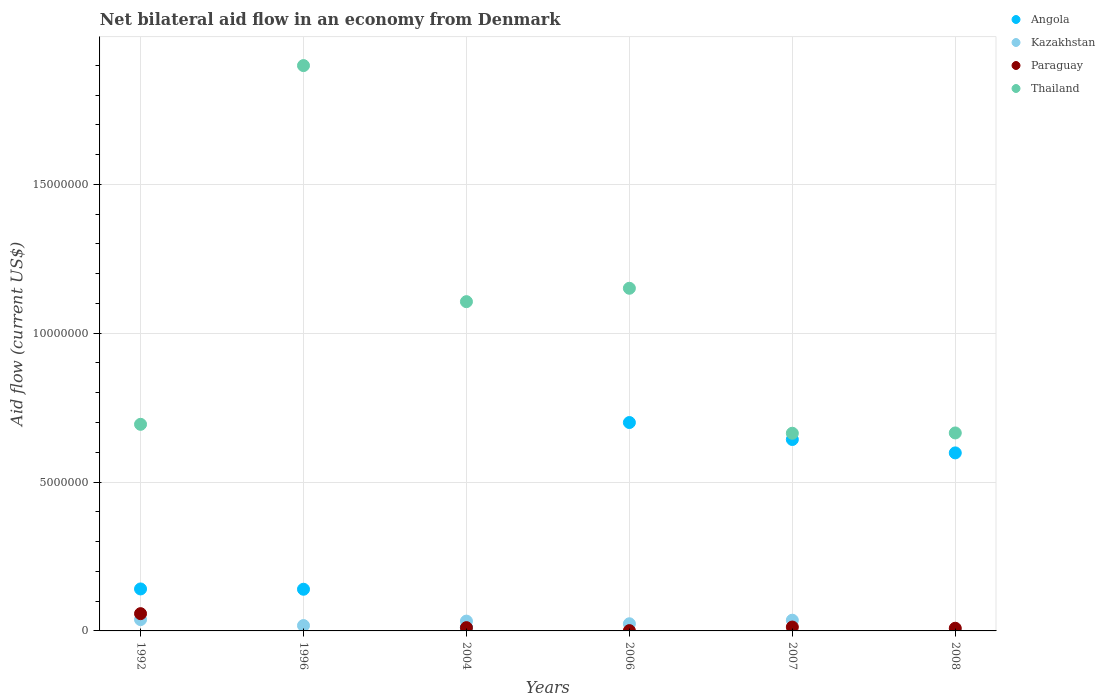In which year was the net bilateral aid flow in Kazakhstan maximum?
Your response must be concise. 1992. What is the total net bilateral aid flow in Angola in the graph?
Offer a very short reply. 2.23e+07. What is the difference between the net bilateral aid flow in Paraguay in 1996 and the net bilateral aid flow in Thailand in 2007?
Offer a terse response. -6.64e+06. What is the average net bilateral aid flow in Kazakhstan per year?
Give a very brief answer. 2.50e+05. In the year 1992, what is the difference between the net bilateral aid flow in Kazakhstan and net bilateral aid flow in Paraguay?
Ensure brevity in your answer.  -2.00e+05. In how many years, is the net bilateral aid flow in Thailand greater than 6000000 US$?
Offer a terse response. 6. What is the ratio of the net bilateral aid flow in Thailand in 2004 to that in 2008?
Your answer should be very brief. 1.66. Is the net bilateral aid flow in Angola in 1992 less than that in 2004?
Make the answer very short. No. What is the difference between the highest and the second highest net bilateral aid flow in Kazakhstan?
Keep it short and to the point. 2.00e+04. What is the difference between the highest and the lowest net bilateral aid flow in Paraguay?
Keep it short and to the point. 5.80e+05. Is the sum of the net bilateral aid flow in Kazakhstan in 1992 and 2007 greater than the maximum net bilateral aid flow in Angola across all years?
Ensure brevity in your answer.  No. Is it the case that in every year, the sum of the net bilateral aid flow in Paraguay and net bilateral aid flow in Angola  is greater than the sum of net bilateral aid flow in Thailand and net bilateral aid flow in Kazakhstan?
Your answer should be compact. Yes. Does the net bilateral aid flow in Thailand monotonically increase over the years?
Keep it short and to the point. No. Is the net bilateral aid flow in Kazakhstan strictly greater than the net bilateral aid flow in Angola over the years?
Keep it short and to the point. No. How many dotlines are there?
Ensure brevity in your answer.  4. How many years are there in the graph?
Offer a terse response. 6. Does the graph contain any zero values?
Ensure brevity in your answer.  Yes. Does the graph contain grids?
Offer a terse response. Yes. Where does the legend appear in the graph?
Offer a very short reply. Top right. How many legend labels are there?
Keep it short and to the point. 4. How are the legend labels stacked?
Ensure brevity in your answer.  Vertical. What is the title of the graph?
Keep it short and to the point. Net bilateral aid flow in an economy from Denmark. Does "Faeroe Islands" appear as one of the legend labels in the graph?
Your response must be concise. No. What is the label or title of the Y-axis?
Provide a succinct answer. Aid flow (current US$). What is the Aid flow (current US$) in Angola in 1992?
Your answer should be compact. 1.41e+06. What is the Aid flow (current US$) in Kazakhstan in 1992?
Keep it short and to the point. 3.80e+05. What is the Aid flow (current US$) of Paraguay in 1992?
Make the answer very short. 5.80e+05. What is the Aid flow (current US$) of Thailand in 1992?
Give a very brief answer. 6.94e+06. What is the Aid flow (current US$) in Angola in 1996?
Keep it short and to the point. 1.40e+06. What is the Aid flow (current US$) in Kazakhstan in 1996?
Your response must be concise. 1.80e+05. What is the Aid flow (current US$) of Thailand in 1996?
Provide a succinct answer. 1.90e+07. What is the Aid flow (current US$) of Thailand in 2004?
Provide a short and direct response. 1.11e+07. What is the Aid flow (current US$) in Angola in 2006?
Give a very brief answer. 7.00e+06. What is the Aid flow (current US$) in Kazakhstan in 2006?
Provide a short and direct response. 2.40e+05. What is the Aid flow (current US$) in Paraguay in 2006?
Ensure brevity in your answer.  10000. What is the Aid flow (current US$) in Thailand in 2006?
Keep it short and to the point. 1.15e+07. What is the Aid flow (current US$) in Angola in 2007?
Provide a short and direct response. 6.43e+06. What is the Aid flow (current US$) in Kazakhstan in 2007?
Your answer should be very brief. 3.60e+05. What is the Aid flow (current US$) in Thailand in 2007?
Your answer should be compact. 6.64e+06. What is the Aid flow (current US$) of Angola in 2008?
Ensure brevity in your answer.  5.98e+06. What is the Aid flow (current US$) in Kazakhstan in 2008?
Make the answer very short. 10000. What is the Aid flow (current US$) in Thailand in 2008?
Offer a very short reply. 6.65e+06. Across all years, what is the maximum Aid flow (current US$) of Angola?
Your answer should be compact. 7.00e+06. Across all years, what is the maximum Aid flow (current US$) in Paraguay?
Your response must be concise. 5.80e+05. Across all years, what is the maximum Aid flow (current US$) in Thailand?
Offer a terse response. 1.90e+07. Across all years, what is the minimum Aid flow (current US$) in Kazakhstan?
Provide a short and direct response. 10000. Across all years, what is the minimum Aid flow (current US$) of Paraguay?
Provide a succinct answer. 0. Across all years, what is the minimum Aid flow (current US$) in Thailand?
Provide a short and direct response. 6.64e+06. What is the total Aid flow (current US$) in Angola in the graph?
Give a very brief answer. 2.23e+07. What is the total Aid flow (current US$) in Kazakhstan in the graph?
Make the answer very short. 1.50e+06. What is the total Aid flow (current US$) of Paraguay in the graph?
Provide a short and direct response. 9.20e+05. What is the total Aid flow (current US$) in Thailand in the graph?
Your answer should be very brief. 6.18e+07. What is the difference between the Aid flow (current US$) of Thailand in 1992 and that in 1996?
Your answer should be very brief. -1.20e+07. What is the difference between the Aid flow (current US$) in Angola in 1992 and that in 2004?
Your answer should be compact. 1.29e+06. What is the difference between the Aid flow (current US$) in Kazakhstan in 1992 and that in 2004?
Your response must be concise. 5.00e+04. What is the difference between the Aid flow (current US$) in Paraguay in 1992 and that in 2004?
Your answer should be compact. 4.70e+05. What is the difference between the Aid flow (current US$) of Thailand in 1992 and that in 2004?
Offer a terse response. -4.12e+06. What is the difference between the Aid flow (current US$) in Angola in 1992 and that in 2006?
Your response must be concise. -5.59e+06. What is the difference between the Aid flow (current US$) in Kazakhstan in 1992 and that in 2006?
Keep it short and to the point. 1.40e+05. What is the difference between the Aid flow (current US$) of Paraguay in 1992 and that in 2006?
Make the answer very short. 5.70e+05. What is the difference between the Aid flow (current US$) of Thailand in 1992 and that in 2006?
Provide a short and direct response. -4.57e+06. What is the difference between the Aid flow (current US$) in Angola in 1992 and that in 2007?
Provide a succinct answer. -5.02e+06. What is the difference between the Aid flow (current US$) in Kazakhstan in 1992 and that in 2007?
Provide a succinct answer. 2.00e+04. What is the difference between the Aid flow (current US$) in Thailand in 1992 and that in 2007?
Offer a terse response. 3.00e+05. What is the difference between the Aid flow (current US$) of Angola in 1992 and that in 2008?
Keep it short and to the point. -4.57e+06. What is the difference between the Aid flow (current US$) of Thailand in 1992 and that in 2008?
Offer a very short reply. 2.90e+05. What is the difference between the Aid flow (current US$) in Angola in 1996 and that in 2004?
Give a very brief answer. 1.28e+06. What is the difference between the Aid flow (current US$) of Thailand in 1996 and that in 2004?
Provide a short and direct response. 7.93e+06. What is the difference between the Aid flow (current US$) of Angola in 1996 and that in 2006?
Give a very brief answer. -5.60e+06. What is the difference between the Aid flow (current US$) of Thailand in 1996 and that in 2006?
Your answer should be compact. 7.48e+06. What is the difference between the Aid flow (current US$) of Angola in 1996 and that in 2007?
Your response must be concise. -5.03e+06. What is the difference between the Aid flow (current US$) in Thailand in 1996 and that in 2007?
Your answer should be compact. 1.24e+07. What is the difference between the Aid flow (current US$) in Angola in 1996 and that in 2008?
Keep it short and to the point. -4.58e+06. What is the difference between the Aid flow (current US$) in Thailand in 1996 and that in 2008?
Offer a terse response. 1.23e+07. What is the difference between the Aid flow (current US$) in Angola in 2004 and that in 2006?
Keep it short and to the point. -6.88e+06. What is the difference between the Aid flow (current US$) in Kazakhstan in 2004 and that in 2006?
Provide a short and direct response. 9.00e+04. What is the difference between the Aid flow (current US$) in Thailand in 2004 and that in 2006?
Give a very brief answer. -4.50e+05. What is the difference between the Aid flow (current US$) of Angola in 2004 and that in 2007?
Ensure brevity in your answer.  -6.31e+06. What is the difference between the Aid flow (current US$) in Paraguay in 2004 and that in 2007?
Your answer should be very brief. -2.00e+04. What is the difference between the Aid flow (current US$) of Thailand in 2004 and that in 2007?
Your answer should be compact. 4.42e+06. What is the difference between the Aid flow (current US$) in Angola in 2004 and that in 2008?
Provide a short and direct response. -5.86e+06. What is the difference between the Aid flow (current US$) of Paraguay in 2004 and that in 2008?
Offer a terse response. 2.00e+04. What is the difference between the Aid flow (current US$) of Thailand in 2004 and that in 2008?
Keep it short and to the point. 4.41e+06. What is the difference between the Aid flow (current US$) of Angola in 2006 and that in 2007?
Make the answer very short. 5.70e+05. What is the difference between the Aid flow (current US$) of Kazakhstan in 2006 and that in 2007?
Provide a short and direct response. -1.20e+05. What is the difference between the Aid flow (current US$) in Paraguay in 2006 and that in 2007?
Offer a very short reply. -1.20e+05. What is the difference between the Aid flow (current US$) in Thailand in 2006 and that in 2007?
Offer a very short reply. 4.87e+06. What is the difference between the Aid flow (current US$) in Angola in 2006 and that in 2008?
Your response must be concise. 1.02e+06. What is the difference between the Aid flow (current US$) in Paraguay in 2006 and that in 2008?
Your response must be concise. -8.00e+04. What is the difference between the Aid flow (current US$) of Thailand in 2006 and that in 2008?
Provide a short and direct response. 4.86e+06. What is the difference between the Aid flow (current US$) in Angola in 2007 and that in 2008?
Provide a short and direct response. 4.50e+05. What is the difference between the Aid flow (current US$) of Thailand in 2007 and that in 2008?
Your answer should be compact. -10000. What is the difference between the Aid flow (current US$) of Angola in 1992 and the Aid flow (current US$) of Kazakhstan in 1996?
Provide a succinct answer. 1.23e+06. What is the difference between the Aid flow (current US$) in Angola in 1992 and the Aid flow (current US$) in Thailand in 1996?
Your response must be concise. -1.76e+07. What is the difference between the Aid flow (current US$) in Kazakhstan in 1992 and the Aid flow (current US$) in Thailand in 1996?
Offer a very short reply. -1.86e+07. What is the difference between the Aid flow (current US$) in Paraguay in 1992 and the Aid flow (current US$) in Thailand in 1996?
Offer a terse response. -1.84e+07. What is the difference between the Aid flow (current US$) in Angola in 1992 and the Aid flow (current US$) in Kazakhstan in 2004?
Offer a very short reply. 1.08e+06. What is the difference between the Aid flow (current US$) of Angola in 1992 and the Aid flow (current US$) of Paraguay in 2004?
Provide a short and direct response. 1.30e+06. What is the difference between the Aid flow (current US$) of Angola in 1992 and the Aid flow (current US$) of Thailand in 2004?
Ensure brevity in your answer.  -9.65e+06. What is the difference between the Aid flow (current US$) of Kazakhstan in 1992 and the Aid flow (current US$) of Thailand in 2004?
Offer a terse response. -1.07e+07. What is the difference between the Aid flow (current US$) in Paraguay in 1992 and the Aid flow (current US$) in Thailand in 2004?
Provide a short and direct response. -1.05e+07. What is the difference between the Aid flow (current US$) in Angola in 1992 and the Aid flow (current US$) in Kazakhstan in 2006?
Provide a short and direct response. 1.17e+06. What is the difference between the Aid flow (current US$) in Angola in 1992 and the Aid flow (current US$) in Paraguay in 2006?
Give a very brief answer. 1.40e+06. What is the difference between the Aid flow (current US$) of Angola in 1992 and the Aid flow (current US$) of Thailand in 2006?
Your answer should be compact. -1.01e+07. What is the difference between the Aid flow (current US$) in Kazakhstan in 1992 and the Aid flow (current US$) in Thailand in 2006?
Offer a terse response. -1.11e+07. What is the difference between the Aid flow (current US$) in Paraguay in 1992 and the Aid flow (current US$) in Thailand in 2006?
Make the answer very short. -1.09e+07. What is the difference between the Aid flow (current US$) in Angola in 1992 and the Aid flow (current US$) in Kazakhstan in 2007?
Ensure brevity in your answer.  1.05e+06. What is the difference between the Aid flow (current US$) in Angola in 1992 and the Aid flow (current US$) in Paraguay in 2007?
Offer a very short reply. 1.28e+06. What is the difference between the Aid flow (current US$) of Angola in 1992 and the Aid flow (current US$) of Thailand in 2007?
Provide a short and direct response. -5.23e+06. What is the difference between the Aid flow (current US$) in Kazakhstan in 1992 and the Aid flow (current US$) in Thailand in 2007?
Your answer should be very brief. -6.26e+06. What is the difference between the Aid flow (current US$) of Paraguay in 1992 and the Aid flow (current US$) of Thailand in 2007?
Provide a succinct answer. -6.06e+06. What is the difference between the Aid flow (current US$) of Angola in 1992 and the Aid flow (current US$) of Kazakhstan in 2008?
Your response must be concise. 1.40e+06. What is the difference between the Aid flow (current US$) in Angola in 1992 and the Aid flow (current US$) in Paraguay in 2008?
Offer a terse response. 1.32e+06. What is the difference between the Aid flow (current US$) in Angola in 1992 and the Aid flow (current US$) in Thailand in 2008?
Provide a succinct answer. -5.24e+06. What is the difference between the Aid flow (current US$) in Kazakhstan in 1992 and the Aid flow (current US$) in Thailand in 2008?
Give a very brief answer. -6.27e+06. What is the difference between the Aid flow (current US$) in Paraguay in 1992 and the Aid flow (current US$) in Thailand in 2008?
Your answer should be compact. -6.07e+06. What is the difference between the Aid flow (current US$) of Angola in 1996 and the Aid flow (current US$) of Kazakhstan in 2004?
Your answer should be compact. 1.07e+06. What is the difference between the Aid flow (current US$) of Angola in 1996 and the Aid flow (current US$) of Paraguay in 2004?
Offer a very short reply. 1.29e+06. What is the difference between the Aid flow (current US$) of Angola in 1996 and the Aid flow (current US$) of Thailand in 2004?
Keep it short and to the point. -9.66e+06. What is the difference between the Aid flow (current US$) of Kazakhstan in 1996 and the Aid flow (current US$) of Thailand in 2004?
Your answer should be very brief. -1.09e+07. What is the difference between the Aid flow (current US$) of Angola in 1996 and the Aid flow (current US$) of Kazakhstan in 2006?
Provide a succinct answer. 1.16e+06. What is the difference between the Aid flow (current US$) of Angola in 1996 and the Aid flow (current US$) of Paraguay in 2006?
Give a very brief answer. 1.39e+06. What is the difference between the Aid flow (current US$) of Angola in 1996 and the Aid flow (current US$) of Thailand in 2006?
Offer a terse response. -1.01e+07. What is the difference between the Aid flow (current US$) in Kazakhstan in 1996 and the Aid flow (current US$) in Thailand in 2006?
Provide a succinct answer. -1.13e+07. What is the difference between the Aid flow (current US$) of Angola in 1996 and the Aid flow (current US$) of Kazakhstan in 2007?
Keep it short and to the point. 1.04e+06. What is the difference between the Aid flow (current US$) of Angola in 1996 and the Aid flow (current US$) of Paraguay in 2007?
Offer a terse response. 1.27e+06. What is the difference between the Aid flow (current US$) of Angola in 1996 and the Aid flow (current US$) of Thailand in 2007?
Your answer should be very brief. -5.24e+06. What is the difference between the Aid flow (current US$) of Kazakhstan in 1996 and the Aid flow (current US$) of Paraguay in 2007?
Give a very brief answer. 5.00e+04. What is the difference between the Aid flow (current US$) in Kazakhstan in 1996 and the Aid flow (current US$) in Thailand in 2007?
Keep it short and to the point. -6.46e+06. What is the difference between the Aid flow (current US$) in Angola in 1996 and the Aid flow (current US$) in Kazakhstan in 2008?
Provide a short and direct response. 1.39e+06. What is the difference between the Aid flow (current US$) of Angola in 1996 and the Aid flow (current US$) of Paraguay in 2008?
Offer a very short reply. 1.31e+06. What is the difference between the Aid flow (current US$) in Angola in 1996 and the Aid flow (current US$) in Thailand in 2008?
Your response must be concise. -5.25e+06. What is the difference between the Aid flow (current US$) in Kazakhstan in 1996 and the Aid flow (current US$) in Paraguay in 2008?
Give a very brief answer. 9.00e+04. What is the difference between the Aid flow (current US$) in Kazakhstan in 1996 and the Aid flow (current US$) in Thailand in 2008?
Provide a short and direct response. -6.47e+06. What is the difference between the Aid flow (current US$) of Angola in 2004 and the Aid flow (current US$) of Kazakhstan in 2006?
Make the answer very short. -1.20e+05. What is the difference between the Aid flow (current US$) in Angola in 2004 and the Aid flow (current US$) in Thailand in 2006?
Offer a terse response. -1.14e+07. What is the difference between the Aid flow (current US$) in Kazakhstan in 2004 and the Aid flow (current US$) in Thailand in 2006?
Provide a succinct answer. -1.12e+07. What is the difference between the Aid flow (current US$) in Paraguay in 2004 and the Aid flow (current US$) in Thailand in 2006?
Ensure brevity in your answer.  -1.14e+07. What is the difference between the Aid flow (current US$) of Angola in 2004 and the Aid flow (current US$) of Kazakhstan in 2007?
Provide a short and direct response. -2.40e+05. What is the difference between the Aid flow (current US$) in Angola in 2004 and the Aid flow (current US$) in Thailand in 2007?
Ensure brevity in your answer.  -6.52e+06. What is the difference between the Aid flow (current US$) in Kazakhstan in 2004 and the Aid flow (current US$) in Paraguay in 2007?
Offer a terse response. 2.00e+05. What is the difference between the Aid flow (current US$) of Kazakhstan in 2004 and the Aid flow (current US$) of Thailand in 2007?
Keep it short and to the point. -6.31e+06. What is the difference between the Aid flow (current US$) of Paraguay in 2004 and the Aid flow (current US$) of Thailand in 2007?
Make the answer very short. -6.53e+06. What is the difference between the Aid flow (current US$) of Angola in 2004 and the Aid flow (current US$) of Kazakhstan in 2008?
Your answer should be very brief. 1.10e+05. What is the difference between the Aid flow (current US$) of Angola in 2004 and the Aid flow (current US$) of Paraguay in 2008?
Provide a short and direct response. 3.00e+04. What is the difference between the Aid flow (current US$) in Angola in 2004 and the Aid flow (current US$) in Thailand in 2008?
Offer a very short reply. -6.53e+06. What is the difference between the Aid flow (current US$) in Kazakhstan in 2004 and the Aid flow (current US$) in Thailand in 2008?
Make the answer very short. -6.32e+06. What is the difference between the Aid flow (current US$) of Paraguay in 2004 and the Aid flow (current US$) of Thailand in 2008?
Provide a succinct answer. -6.54e+06. What is the difference between the Aid flow (current US$) in Angola in 2006 and the Aid flow (current US$) in Kazakhstan in 2007?
Ensure brevity in your answer.  6.64e+06. What is the difference between the Aid flow (current US$) of Angola in 2006 and the Aid flow (current US$) of Paraguay in 2007?
Your answer should be compact. 6.87e+06. What is the difference between the Aid flow (current US$) in Kazakhstan in 2006 and the Aid flow (current US$) in Thailand in 2007?
Your answer should be compact. -6.40e+06. What is the difference between the Aid flow (current US$) of Paraguay in 2006 and the Aid flow (current US$) of Thailand in 2007?
Offer a terse response. -6.63e+06. What is the difference between the Aid flow (current US$) in Angola in 2006 and the Aid flow (current US$) in Kazakhstan in 2008?
Your answer should be compact. 6.99e+06. What is the difference between the Aid flow (current US$) in Angola in 2006 and the Aid flow (current US$) in Paraguay in 2008?
Offer a terse response. 6.91e+06. What is the difference between the Aid flow (current US$) in Angola in 2006 and the Aid flow (current US$) in Thailand in 2008?
Make the answer very short. 3.50e+05. What is the difference between the Aid flow (current US$) in Kazakhstan in 2006 and the Aid flow (current US$) in Paraguay in 2008?
Your answer should be compact. 1.50e+05. What is the difference between the Aid flow (current US$) in Kazakhstan in 2006 and the Aid flow (current US$) in Thailand in 2008?
Give a very brief answer. -6.41e+06. What is the difference between the Aid flow (current US$) of Paraguay in 2006 and the Aid flow (current US$) of Thailand in 2008?
Give a very brief answer. -6.64e+06. What is the difference between the Aid flow (current US$) in Angola in 2007 and the Aid flow (current US$) in Kazakhstan in 2008?
Provide a short and direct response. 6.42e+06. What is the difference between the Aid flow (current US$) in Angola in 2007 and the Aid flow (current US$) in Paraguay in 2008?
Your response must be concise. 6.34e+06. What is the difference between the Aid flow (current US$) of Angola in 2007 and the Aid flow (current US$) of Thailand in 2008?
Your response must be concise. -2.20e+05. What is the difference between the Aid flow (current US$) in Kazakhstan in 2007 and the Aid flow (current US$) in Thailand in 2008?
Your answer should be very brief. -6.29e+06. What is the difference between the Aid flow (current US$) in Paraguay in 2007 and the Aid flow (current US$) in Thailand in 2008?
Your answer should be compact. -6.52e+06. What is the average Aid flow (current US$) in Angola per year?
Provide a short and direct response. 3.72e+06. What is the average Aid flow (current US$) of Paraguay per year?
Offer a very short reply. 1.53e+05. What is the average Aid flow (current US$) in Thailand per year?
Provide a succinct answer. 1.03e+07. In the year 1992, what is the difference between the Aid flow (current US$) of Angola and Aid flow (current US$) of Kazakhstan?
Ensure brevity in your answer.  1.03e+06. In the year 1992, what is the difference between the Aid flow (current US$) of Angola and Aid flow (current US$) of Paraguay?
Keep it short and to the point. 8.30e+05. In the year 1992, what is the difference between the Aid flow (current US$) of Angola and Aid flow (current US$) of Thailand?
Provide a succinct answer. -5.53e+06. In the year 1992, what is the difference between the Aid flow (current US$) in Kazakhstan and Aid flow (current US$) in Thailand?
Ensure brevity in your answer.  -6.56e+06. In the year 1992, what is the difference between the Aid flow (current US$) in Paraguay and Aid flow (current US$) in Thailand?
Provide a succinct answer. -6.36e+06. In the year 1996, what is the difference between the Aid flow (current US$) of Angola and Aid flow (current US$) of Kazakhstan?
Your response must be concise. 1.22e+06. In the year 1996, what is the difference between the Aid flow (current US$) of Angola and Aid flow (current US$) of Thailand?
Provide a succinct answer. -1.76e+07. In the year 1996, what is the difference between the Aid flow (current US$) in Kazakhstan and Aid flow (current US$) in Thailand?
Give a very brief answer. -1.88e+07. In the year 2004, what is the difference between the Aid flow (current US$) of Angola and Aid flow (current US$) of Paraguay?
Ensure brevity in your answer.  10000. In the year 2004, what is the difference between the Aid flow (current US$) of Angola and Aid flow (current US$) of Thailand?
Your answer should be very brief. -1.09e+07. In the year 2004, what is the difference between the Aid flow (current US$) of Kazakhstan and Aid flow (current US$) of Paraguay?
Make the answer very short. 2.20e+05. In the year 2004, what is the difference between the Aid flow (current US$) in Kazakhstan and Aid flow (current US$) in Thailand?
Give a very brief answer. -1.07e+07. In the year 2004, what is the difference between the Aid flow (current US$) of Paraguay and Aid flow (current US$) of Thailand?
Your answer should be very brief. -1.10e+07. In the year 2006, what is the difference between the Aid flow (current US$) of Angola and Aid flow (current US$) of Kazakhstan?
Your answer should be compact. 6.76e+06. In the year 2006, what is the difference between the Aid flow (current US$) in Angola and Aid flow (current US$) in Paraguay?
Offer a very short reply. 6.99e+06. In the year 2006, what is the difference between the Aid flow (current US$) of Angola and Aid flow (current US$) of Thailand?
Offer a terse response. -4.51e+06. In the year 2006, what is the difference between the Aid flow (current US$) in Kazakhstan and Aid flow (current US$) in Paraguay?
Provide a succinct answer. 2.30e+05. In the year 2006, what is the difference between the Aid flow (current US$) in Kazakhstan and Aid flow (current US$) in Thailand?
Give a very brief answer. -1.13e+07. In the year 2006, what is the difference between the Aid flow (current US$) of Paraguay and Aid flow (current US$) of Thailand?
Give a very brief answer. -1.15e+07. In the year 2007, what is the difference between the Aid flow (current US$) in Angola and Aid flow (current US$) in Kazakhstan?
Your answer should be very brief. 6.07e+06. In the year 2007, what is the difference between the Aid flow (current US$) of Angola and Aid flow (current US$) of Paraguay?
Keep it short and to the point. 6.30e+06. In the year 2007, what is the difference between the Aid flow (current US$) in Kazakhstan and Aid flow (current US$) in Thailand?
Offer a terse response. -6.28e+06. In the year 2007, what is the difference between the Aid flow (current US$) of Paraguay and Aid flow (current US$) of Thailand?
Provide a succinct answer. -6.51e+06. In the year 2008, what is the difference between the Aid flow (current US$) of Angola and Aid flow (current US$) of Kazakhstan?
Your answer should be compact. 5.97e+06. In the year 2008, what is the difference between the Aid flow (current US$) of Angola and Aid flow (current US$) of Paraguay?
Offer a terse response. 5.89e+06. In the year 2008, what is the difference between the Aid flow (current US$) in Angola and Aid flow (current US$) in Thailand?
Your response must be concise. -6.70e+05. In the year 2008, what is the difference between the Aid flow (current US$) in Kazakhstan and Aid flow (current US$) in Paraguay?
Ensure brevity in your answer.  -8.00e+04. In the year 2008, what is the difference between the Aid flow (current US$) of Kazakhstan and Aid flow (current US$) of Thailand?
Ensure brevity in your answer.  -6.64e+06. In the year 2008, what is the difference between the Aid flow (current US$) of Paraguay and Aid flow (current US$) of Thailand?
Your answer should be compact. -6.56e+06. What is the ratio of the Aid flow (current US$) of Angola in 1992 to that in 1996?
Offer a terse response. 1.01. What is the ratio of the Aid flow (current US$) of Kazakhstan in 1992 to that in 1996?
Ensure brevity in your answer.  2.11. What is the ratio of the Aid flow (current US$) of Thailand in 1992 to that in 1996?
Give a very brief answer. 0.37. What is the ratio of the Aid flow (current US$) of Angola in 1992 to that in 2004?
Provide a succinct answer. 11.75. What is the ratio of the Aid flow (current US$) in Kazakhstan in 1992 to that in 2004?
Your response must be concise. 1.15. What is the ratio of the Aid flow (current US$) in Paraguay in 1992 to that in 2004?
Your response must be concise. 5.27. What is the ratio of the Aid flow (current US$) in Thailand in 1992 to that in 2004?
Make the answer very short. 0.63. What is the ratio of the Aid flow (current US$) of Angola in 1992 to that in 2006?
Ensure brevity in your answer.  0.2. What is the ratio of the Aid flow (current US$) of Kazakhstan in 1992 to that in 2006?
Provide a short and direct response. 1.58. What is the ratio of the Aid flow (current US$) of Paraguay in 1992 to that in 2006?
Provide a short and direct response. 58. What is the ratio of the Aid flow (current US$) in Thailand in 1992 to that in 2006?
Your answer should be very brief. 0.6. What is the ratio of the Aid flow (current US$) of Angola in 1992 to that in 2007?
Keep it short and to the point. 0.22. What is the ratio of the Aid flow (current US$) in Kazakhstan in 1992 to that in 2007?
Your answer should be compact. 1.06. What is the ratio of the Aid flow (current US$) in Paraguay in 1992 to that in 2007?
Make the answer very short. 4.46. What is the ratio of the Aid flow (current US$) in Thailand in 1992 to that in 2007?
Keep it short and to the point. 1.05. What is the ratio of the Aid flow (current US$) in Angola in 1992 to that in 2008?
Your response must be concise. 0.24. What is the ratio of the Aid flow (current US$) in Paraguay in 1992 to that in 2008?
Make the answer very short. 6.44. What is the ratio of the Aid flow (current US$) of Thailand in 1992 to that in 2008?
Offer a terse response. 1.04. What is the ratio of the Aid flow (current US$) in Angola in 1996 to that in 2004?
Keep it short and to the point. 11.67. What is the ratio of the Aid flow (current US$) in Kazakhstan in 1996 to that in 2004?
Offer a terse response. 0.55. What is the ratio of the Aid flow (current US$) of Thailand in 1996 to that in 2004?
Your answer should be compact. 1.72. What is the ratio of the Aid flow (current US$) of Angola in 1996 to that in 2006?
Provide a short and direct response. 0.2. What is the ratio of the Aid flow (current US$) of Thailand in 1996 to that in 2006?
Ensure brevity in your answer.  1.65. What is the ratio of the Aid flow (current US$) of Angola in 1996 to that in 2007?
Your response must be concise. 0.22. What is the ratio of the Aid flow (current US$) of Thailand in 1996 to that in 2007?
Make the answer very short. 2.86. What is the ratio of the Aid flow (current US$) in Angola in 1996 to that in 2008?
Offer a terse response. 0.23. What is the ratio of the Aid flow (current US$) of Kazakhstan in 1996 to that in 2008?
Keep it short and to the point. 18. What is the ratio of the Aid flow (current US$) of Thailand in 1996 to that in 2008?
Offer a very short reply. 2.86. What is the ratio of the Aid flow (current US$) in Angola in 2004 to that in 2006?
Your answer should be very brief. 0.02. What is the ratio of the Aid flow (current US$) of Kazakhstan in 2004 to that in 2006?
Offer a terse response. 1.38. What is the ratio of the Aid flow (current US$) of Paraguay in 2004 to that in 2006?
Give a very brief answer. 11. What is the ratio of the Aid flow (current US$) in Thailand in 2004 to that in 2006?
Ensure brevity in your answer.  0.96. What is the ratio of the Aid flow (current US$) in Angola in 2004 to that in 2007?
Offer a terse response. 0.02. What is the ratio of the Aid flow (current US$) in Kazakhstan in 2004 to that in 2007?
Keep it short and to the point. 0.92. What is the ratio of the Aid flow (current US$) in Paraguay in 2004 to that in 2007?
Provide a succinct answer. 0.85. What is the ratio of the Aid flow (current US$) in Thailand in 2004 to that in 2007?
Your answer should be very brief. 1.67. What is the ratio of the Aid flow (current US$) in Angola in 2004 to that in 2008?
Offer a terse response. 0.02. What is the ratio of the Aid flow (current US$) in Paraguay in 2004 to that in 2008?
Your answer should be very brief. 1.22. What is the ratio of the Aid flow (current US$) of Thailand in 2004 to that in 2008?
Offer a terse response. 1.66. What is the ratio of the Aid flow (current US$) of Angola in 2006 to that in 2007?
Your answer should be compact. 1.09. What is the ratio of the Aid flow (current US$) of Kazakhstan in 2006 to that in 2007?
Keep it short and to the point. 0.67. What is the ratio of the Aid flow (current US$) in Paraguay in 2006 to that in 2007?
Your response must be concise. 0.08. What is the ratio of the Aid flow (current US$) of Thailand in 2006 to that in 2007?
Ensure brevity in your answer.  1.73. What is the ratio of the Aid flow (current US$) of Angola in 2006 to that in 2008?
Ensure brevity in your answer.  1.17. What is the ratio of the Aid flow (current US$) in Paraguay in 2006 to that in 2008?
Provide a succinct answer. 0.11. What is the ratio of the Aid flow (current US$) of Thailand in 2006 to that in 2008?
Offer a terse response. 1.73. What is the ratio of the Aid flow (current US$) of Angola in 2007 to that in 2008?
Keep it short and to the point. 1.08. What is the ratio of the Aid flow (current US$) in Kazakhstan in 2007 to that in 2008?
Give a very brief answer. 36. What is the ratio of the Aid flow (current US$) in Paraguay in 2007 to that in 2008?
Keep it short and to the point. 1.44. What is the ratio of the Aid flow (current US$) in Thailand in 2007 to that in 2008?
Ensure brevity in your answer.  1. What is the difference between the highest and the second highest Aid flow (current US$) of Angola?
Your response must be concise. 5.70e+05. What is the difference between the highest and the second highest Aid flow (current US$) of Kazakhstan?
Your answer should be compact. 2.00e+04. What is the difference between the highest and the second highest Aid flow (current US$) in Paraguay?
Offer a very short reply. 4.50e+05. What is the difference between the highest and the second highest Aid flow (current US$) of Thailand?
Provide a short and direct response. 7.48e+06. What is the difference between the highest and the lowest Aid flow (current US$) in Angola?
Provide a succinct answer. 6.88e+06. What is the difference between the highest and the lowest Aid flow (current US$) in Kazakhstan?
Your answer should be compact. 3.70e+05. What is the difference between the highest and the lowest Aid flow (current US$) in Paraguay?
Provide a short and direct response. 5.80e+05. What is the difference between the highest and the lowest Aid flow (current US$) of Thailand?
Your answer should be compact. 1.24e+07. 